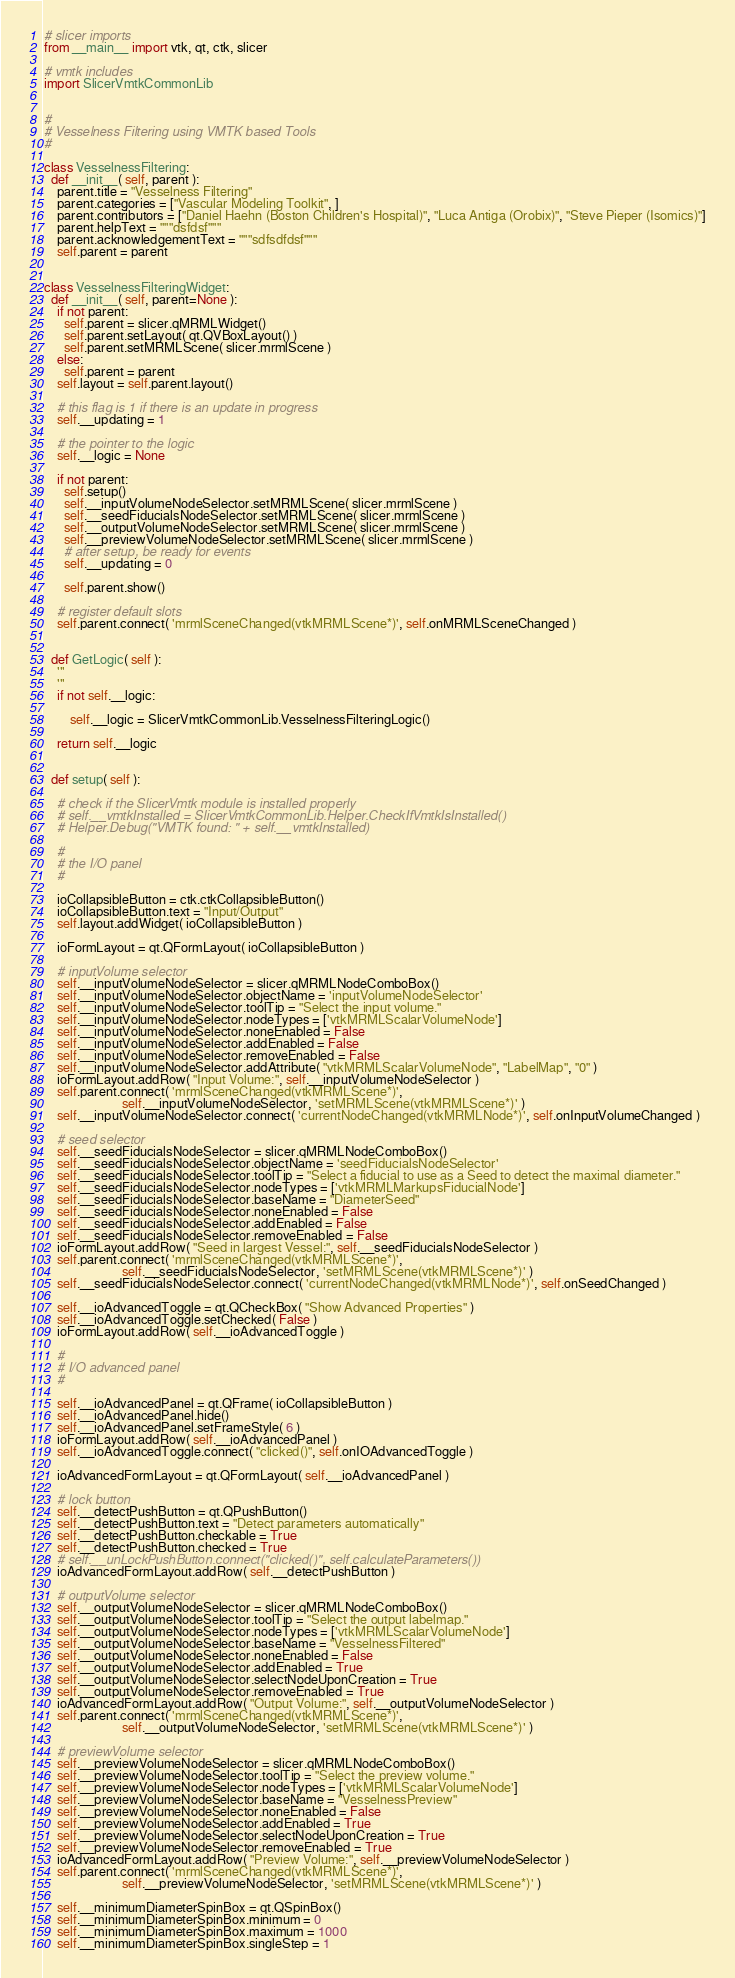<code> <loc_0><loc_0><loc_500><loc_500><_Python_># slicer imports
from __main__ import vtk, qt, ctk, slicer

# vmtk includes
import SlicerVmtkCommonLib


#
# Vesselness Filtering using VMTK based Tools
#

class VesselnessFiltering:
  def __init__( self, parent ):
    parent.title = "Vesselness Filtering"
    parent.categories = ["Vascular Modeling Toolkit", ]
    parent.contributors = ["Daniel Haehn (Boston Children's Hospital)", "Luca Antiga (Orobix)", "Steve Pieper (Isomics)"]
    parent.helpText = """dsfdsf"""
    parent.acknowledgementText = """sdfsdfdsf"""
    self.parent = parent


class VesselnessFilteringWidget:
  def __init__( self, parent=None ):
    if not parent:
      self.parent = slicer.qMRMLWidget()
      self.parent.setLayout( qt.QVBoxLayout() )
      self.parent.setMRMLScene( slicer.mrmlScene )
    else:
      self.parent = parent
    self.layout = self.parent.layout()

    # this flag is 1 if there is an update in progress
    self.__updating = 1

    # the pointer to the logic
    self.__logic = None

    if not parent:
      self.setup()
      self.__inputVolumeNodeSelector.setMRMLScene( slicer.mrmlScene )
      self.__seedFiducialsNodeSelector.setMRMLScene( slicer.mrmlScene )
      self.__outputVolumeNodeSelector.setMRMLScene( slicer.mrmlScene )
      self.__previewVolumeNodeSelector.setMRMLScene( slicer.mrmlScene )
      # after setup, be ready for events
      self.__updating = 0

      self.parent.show()

    # register default slots
    self.parent.connect( 'mrmlSceneChanged(vtkMRMLScene*)', self.onMRMLSceneChanged )


  def GetLogic( self ):
    '''
    '''
    if not self.__logic:

        self.__logic = SlicerVmtkCommonLib.VesselnessFilteringLogic()

    return self.__logic


  def setup( self ):

    # check if the SlicerVmtk module is installed properly
    # self.__vmtkInstalled = SlicerVmtkCommonLib.Helper.CheckIfVmtkIsInstalled()
    # Helper.Debug("VMTK found: " + self.__vmtkInstalled)

    #
    # the I/O panel
    #

    ioCollapsibleButton = ctk.ctkCollapsibleButton()
    ioCollapsibleButton.text = "Input/Output"
    self.layout.addWidget( ioCollapsibleButton )

    ioFormLayout = qt.QFormLayout( ioCollapsibleButton )

    # inputVolume selector
    self.__inputVolumeNodeSelector = slicer.qMRMLNodeComboBox()
    self.__inputVolumeNodeSelector.objectName = 'inputVolumeNodeSelector'
    self.__inputVolumeNodeSelector.toolTip = "Select the input volume."
    self.__inputVolumeNodeSelector.nodeTypes = ['vtkMRMLScalarVolumeNode']
    self.__inputVolumeNodeSelector.noneEnabled = False
    self.__inputVolumeNodeSelector.addEnabled = False
    self.__inputVolumeNodeSelector.removeEnabled = False
    self.__inputVolumeNodeSelector.addAttribute( "vtkMRMLScalarVolumeNode", "LabelMap", "0" )
    ioFormLayout.addRow( "Input Volume:", self.__inputVolumeNodeSelector )
    self.parent.connect( 'mrmlSceneChanged(vtkMRMLScene*)',
                        self.__inputVolumeNodeSelector, 'setMRMLScene(vtkMRMLScene*)' )
    self.__inputVolumeNodeSelector.connect( 'currentNodeChanged(vtkMRMLNode*)', self.onInputVolumeChanged )

    # seed selector
    self.__seedFiducialsNodeSelector = slicer.qMRMLNodeComboBox()
    self.__seedFiducialsNodeSelector.objectName = 'seedFiducialsNodeSelector'
    self.__seedFiducialsNodeSelector.toolTip = "Select a fiducial to use as a Seed to detect the maximal diameter."
    self.__seedFiducialsNodeSelector.nodeTypes = ['vtkMRMLMarkupsFiducialNode']
    self.__seedFiducialsNodeSelector.baseName = "DiameterSeed"
    self.__seedFiducialsNodeSelector.noneEnabled = False
    self.__seedFiducialsNodeSelector.addEnabled = False
    self.__seedFiducialsNodeSelector.removeEnabled = False
    ioFormLayout.addRow( "Seed in largest Vessel:", self.__seedFiducialsNodeSelector )
    self.parent.connect( 'mrmlSceneChanged(vtkMRMLScene*)',
                        self.__seedFiducialsNodeSelector, 'setMRMLScene(vtkMRMLScene*)' )
    self.__seedFiducialsNodeSelector.connect( 'currentNodeChanged(vtkMRMLNode*)', self.onSeedChanged )

    self.__ioAdvancedToggle = qt.QCheckBox( "Show Advanced Properties" )
    self.__ioAdvancedToggle.setChecked( False )
    ioFormLayout.addRow( self.__ioAdvancedToggle )

    #
    # I/O advanced panel
    #

    self.__ioAdvancedPanel = qt.QFrame( ioCollapsibleButton )
    self.__ioAdvancedPanel.hide()
    self.__ioAdvancedPanel.setFrameStyle( 6 )
    ioFormLayout.addRow( self.__ioAdvancedPanel )
    self.__ioAdvancedToggle.connect( "clicked()", self.onIOAdvancedToggle )

    ioAdvancedFormLayout = qt.QFormLayout( self.__ioAdvancedPanel )

    # lock button
    self.__detectPushButton = qt.QPushButton()
    self.__detectPushButton.text = "Detect parameters automatically"
    self.__detectPushButton.checkable = True
    self.__detectPushButton.checked = True
    # self.__unLockPushButton.connect("clicked()", self.calculateParameters())
    ioAdvancedFormLayout.addRow( self.__detectPushButton )

    # outputVolume selector
    self.__outputVolumeNodeSelector = slicer.qMRMLNodeComboBox()
    self.__outputVolumeNodeSelector.toolTip = "Select the output labelmap."
    self.__outputVolumeNodeSelector.nodeTypes = ['vtkMRMLScalarVolumeNode']
    self.__outputVolumeNodeSelector.baseName = "VesselnessFiltered"
    self.__outputVolumeNodeSelector.noneEnabled = False
    self.__outputVolumeNodeSelector.addEnabled = True
    self.__outputVolumeNodeSelector.selectNodeUponCreation = True
    self.__outputVolumeNodeSelector.removeEnabled = True
    ioAdvancedFormLayout.addRow( "Output Volume:", self.__outputVolumeNodeSelector )
    self.parent.connect( 'mrmlSceneChanged(vtkMRMLScene*)',
                        self.__outputVolumeNodeSelector, 'setMRMLScene(vtkMRMLScene*)' )

    # previewVolume selector
    self.__previewVolumeNodeSelector = slicer.qMRMLNodeComboBox()
    self.__previewVolumeNodeSelector.toolTip = "Select the preview volume."
    self.__previewVolumeNodeSelector.nodeTypes = ['vtkMRMLScalarVolumeNode']
    self.__previewVolumeNodeSelector.baseName = "VesselnessPreview"
    self.__previewVolumeNodeSelector.noneEnabled = False
    self.__previewVolumeNodeSelector.addEnabled = True
    self.__previewVolumeNodeSelector.selectNodeUponCreation = True
    self.__previewVolumeNodeSelector.removeEnabled = True
    ioAdvancedFormLayout.addRow( "Preview Volume:", self.__previewVolumeNodeSelector )
    self.parent.connect( 'mrmlSceneChanged(vtkMRMLScene*)',
                        self.__previewVolumeNodeSelector, 'setMRMLScene(vtkMRMLScene*)' )

    self.__minimumDiameterSpinBox = qt.QSpinBox()
    self.__minimumDiameterSpinBox.minimum = 0
    self.__minimumDiameterSpinBox.maximum = 1000
    self.__minimumDiameterSpinBox.singleStep = 1</code> 